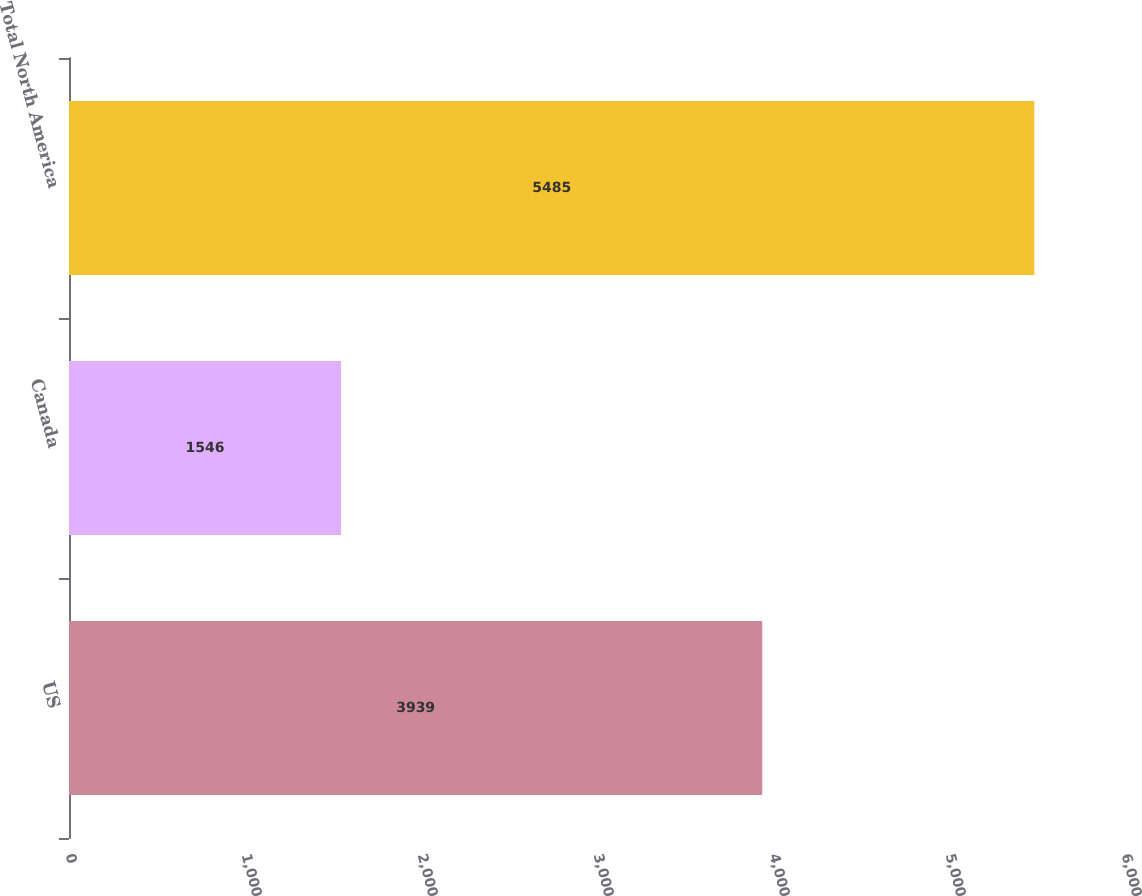<chart> <loc_0><loc_0><loc_500><loc_500><bar_chart><fcel>US<fcel>Canada<fcel>Total North America<nl><fcel>3939<fcel>1546<fcel>5485<nl></chart> 